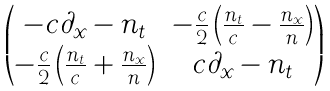Convert formula to latex. <formula><loc_0><loc_0><loc_500><loc_500>\begin{pmatrix} - c \partial _ { x } - n _ { t } & - \frac { c } { 2 } \left ( \frac { n _ { t } } { c } - \frac { n _ { x } } { n } \right ) \\ - \frac { c } { 2 } \left ( \frac { n _ { t } } { c } + \frac { n _ { x } } { n } \right ) & c \partial _ { x } - n _ { t } \end{pmatrix}</formula> 